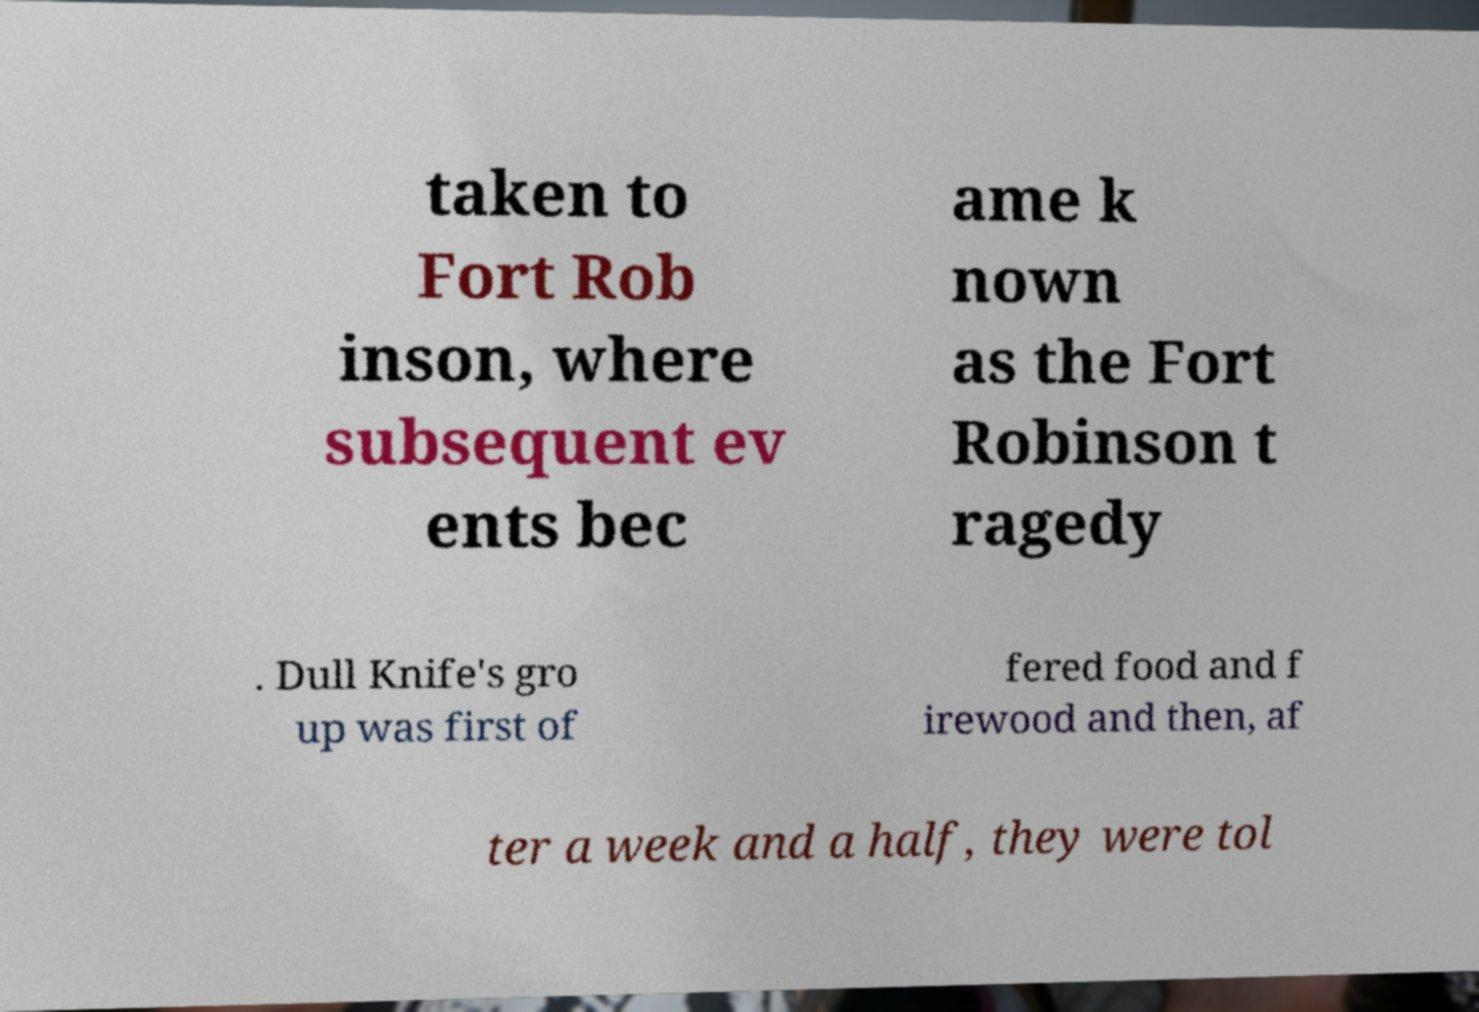There's text embedded in this image that I need extracted. Can you transcribe it verbatim? taken to Fort Rob inson, where subsequent ev ents bec ame k nown as the Fort Robinson t ragedy . Dull Knife's gro up was first of fered food and f irewood and then, af ter a week and a half, they were tol 